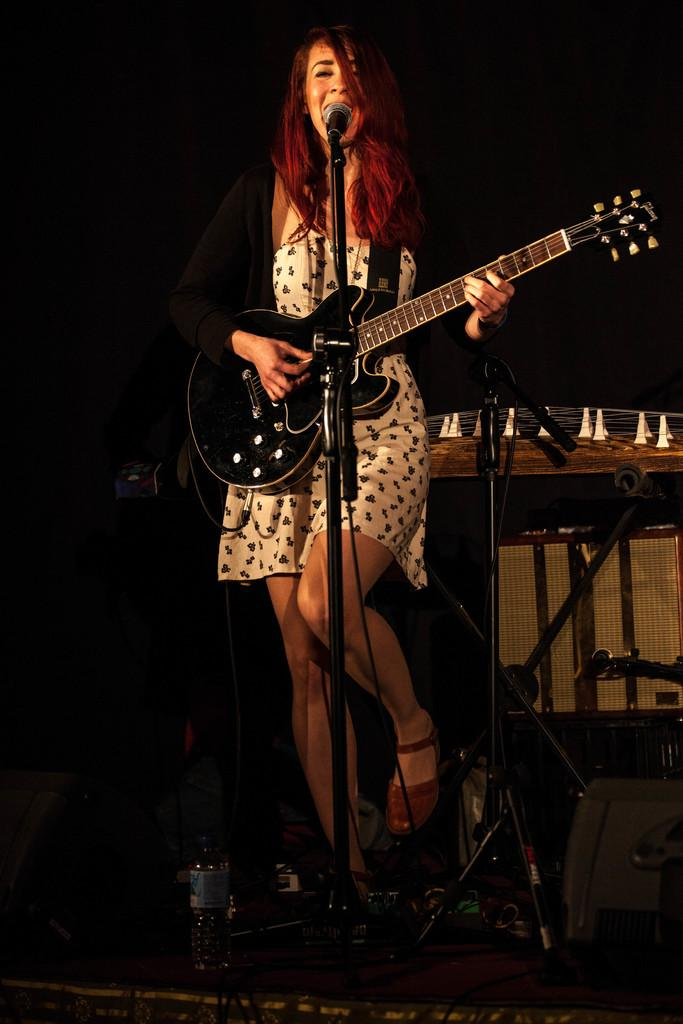Who is the main subject in the image? There is a woman in the image. What is the woman doing in the image? The woman is singing and playing a guitar. What object is the woman holding in the image? The woman is holding a microphone in the image. What type of plants can be seen growing near the woman in the image? There are no plants visible in the image. How does the woman move around while playing the guitar and singing in the image? The image does not show the woman moving around; she is stationary while playing the guitar and singing. 